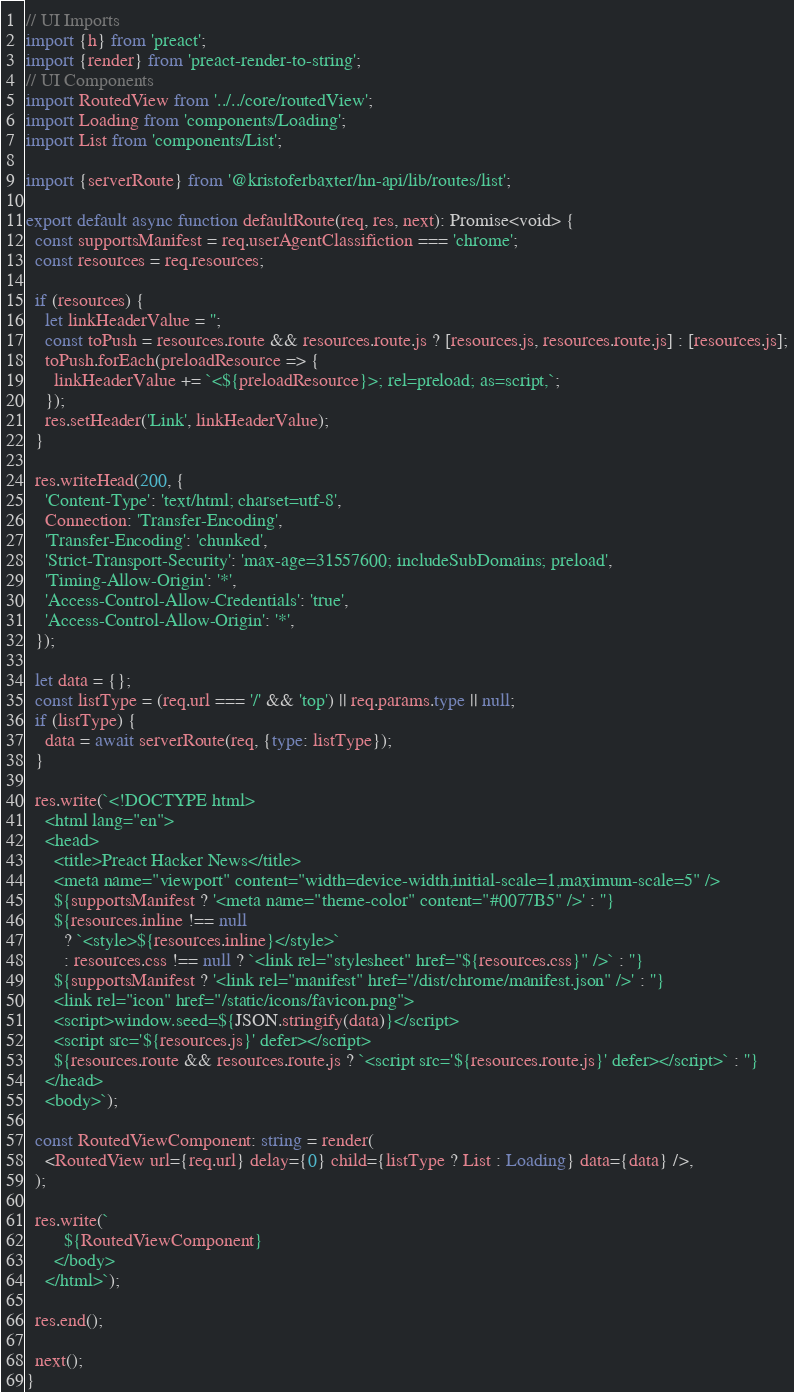<code> <loc_0><loc_0><loc_500><loc_500><_TypeScript_>// UI Imports
import {h} from 'preact';
import {render} from 'preact-render-to-string';
// UI Components
import RoutedView from '../../core/routedView';
import Loading from 'components/Loading';
import List from 'components/List';

import {serverRoute} from '@kristoferbaxter/hn-api/lib/routes/list';

export default async function defaultRoute(req, res, next): Promise<void> {
  const supportsManifest = req.userAgentClassifiction === 'chrome';
  const resources = req.resources;

  if (resources) {
    let linkHeaderValue = '';
    const toPush = resources.route && resources.route.js ? [resources.js, resources.route.js] : [resources.js];
    toPush.forEach(preloadResource => {
      linkHeaderValue += `<${preloadResource}>; rel=preload; as=script,`;
    });
    res.setHeader('Link', linkHeaderValue);
  }

  res.writeHead(200, {
    'Content-Type': 'text/html; charset=utf-8',
    Connection: 'Transfer-Encoding',
    'Transfer-Encoding': 'chunked',
    'Strict-Transport-Security': 'max-age=31557600; includeSubDomains; preload',
    'Timing-Allow-Origin': '*',
    'Access-Control-Allow-Credentials': 'true',
    'Access-Control-Allow-Origin': '*',
  });

  let data = {};
  const listType = (req.url === '/' && 'top') || req.params.type || null;
  if (listType) {
    data = await serverRoute(req, {type: listType});
  }

  res.write(`<!DOCTYPE html>
    <html lang="en">
    <head>
      <title>Preact Hacker News</title>
      <meta name="viewport" content="width=device-width,initial-scale=1,maximum-scale=5" />
      ${supportsManifest ? '<meta name="theme-color" content="#0077B5" />' : ''}
      ${resources.inline !== null
        ? `<style>${resources.inline}</style>`
        : resources.css !== null ? `<link rel="stylesheet" href="${resources.css}" />` : ''}
      ${supportsManifest ? '<link rel="manifest" href="/dist/chrome/manifest.json" />' : ''}
      <link rel="icon" href="/static/icons/favicon.png">
      <script>window.seed=${JSON.stringify(data)}</script>
      <script src='${resources.js}' defer></script>
      ${resources.route && resources.route.js ? `<script src='${resources.route.js}' defer></script>` : ''}
    </head>
    <body>`);

  const RoutedViewComponent: string = render(
    <RoutedView url={req.url} delay={0} child={listType ? List : Loading} data={data} />,
  );

  res.write(`
        ${RoutedViewComponent}
      </body>
    </html>`);

  res.end();

  next();
}
</code> 